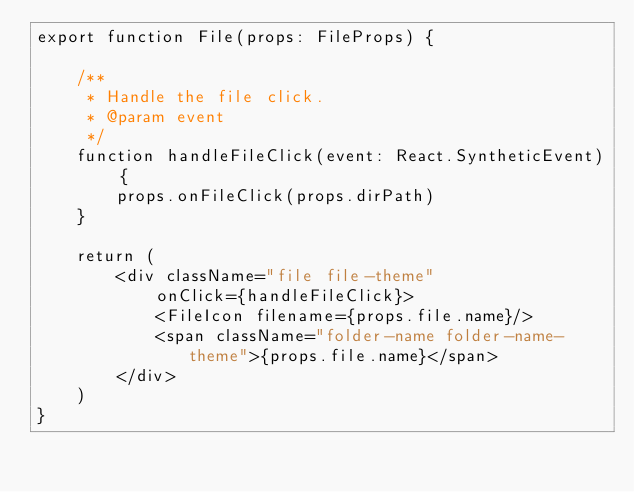<code> <loc_0><loc_0><loc_500><loc_500><_TypeScript_>export function File(props: FileProps) {

    /**
     * Handle the file click.
     * @param event 
     */
    function handleFileClick(event: React.SyntheticEvent) {
        props.onFileClick(props.dirPath)
    }

    return (
        <div className="file file-theme"
            onClick={handleFileClick}>
            <FileIcon filename={props.file.name}/>
            <span className="folder-name folder-name-theme">{props.file.name}</span>
        </div>
    )
}</code> 